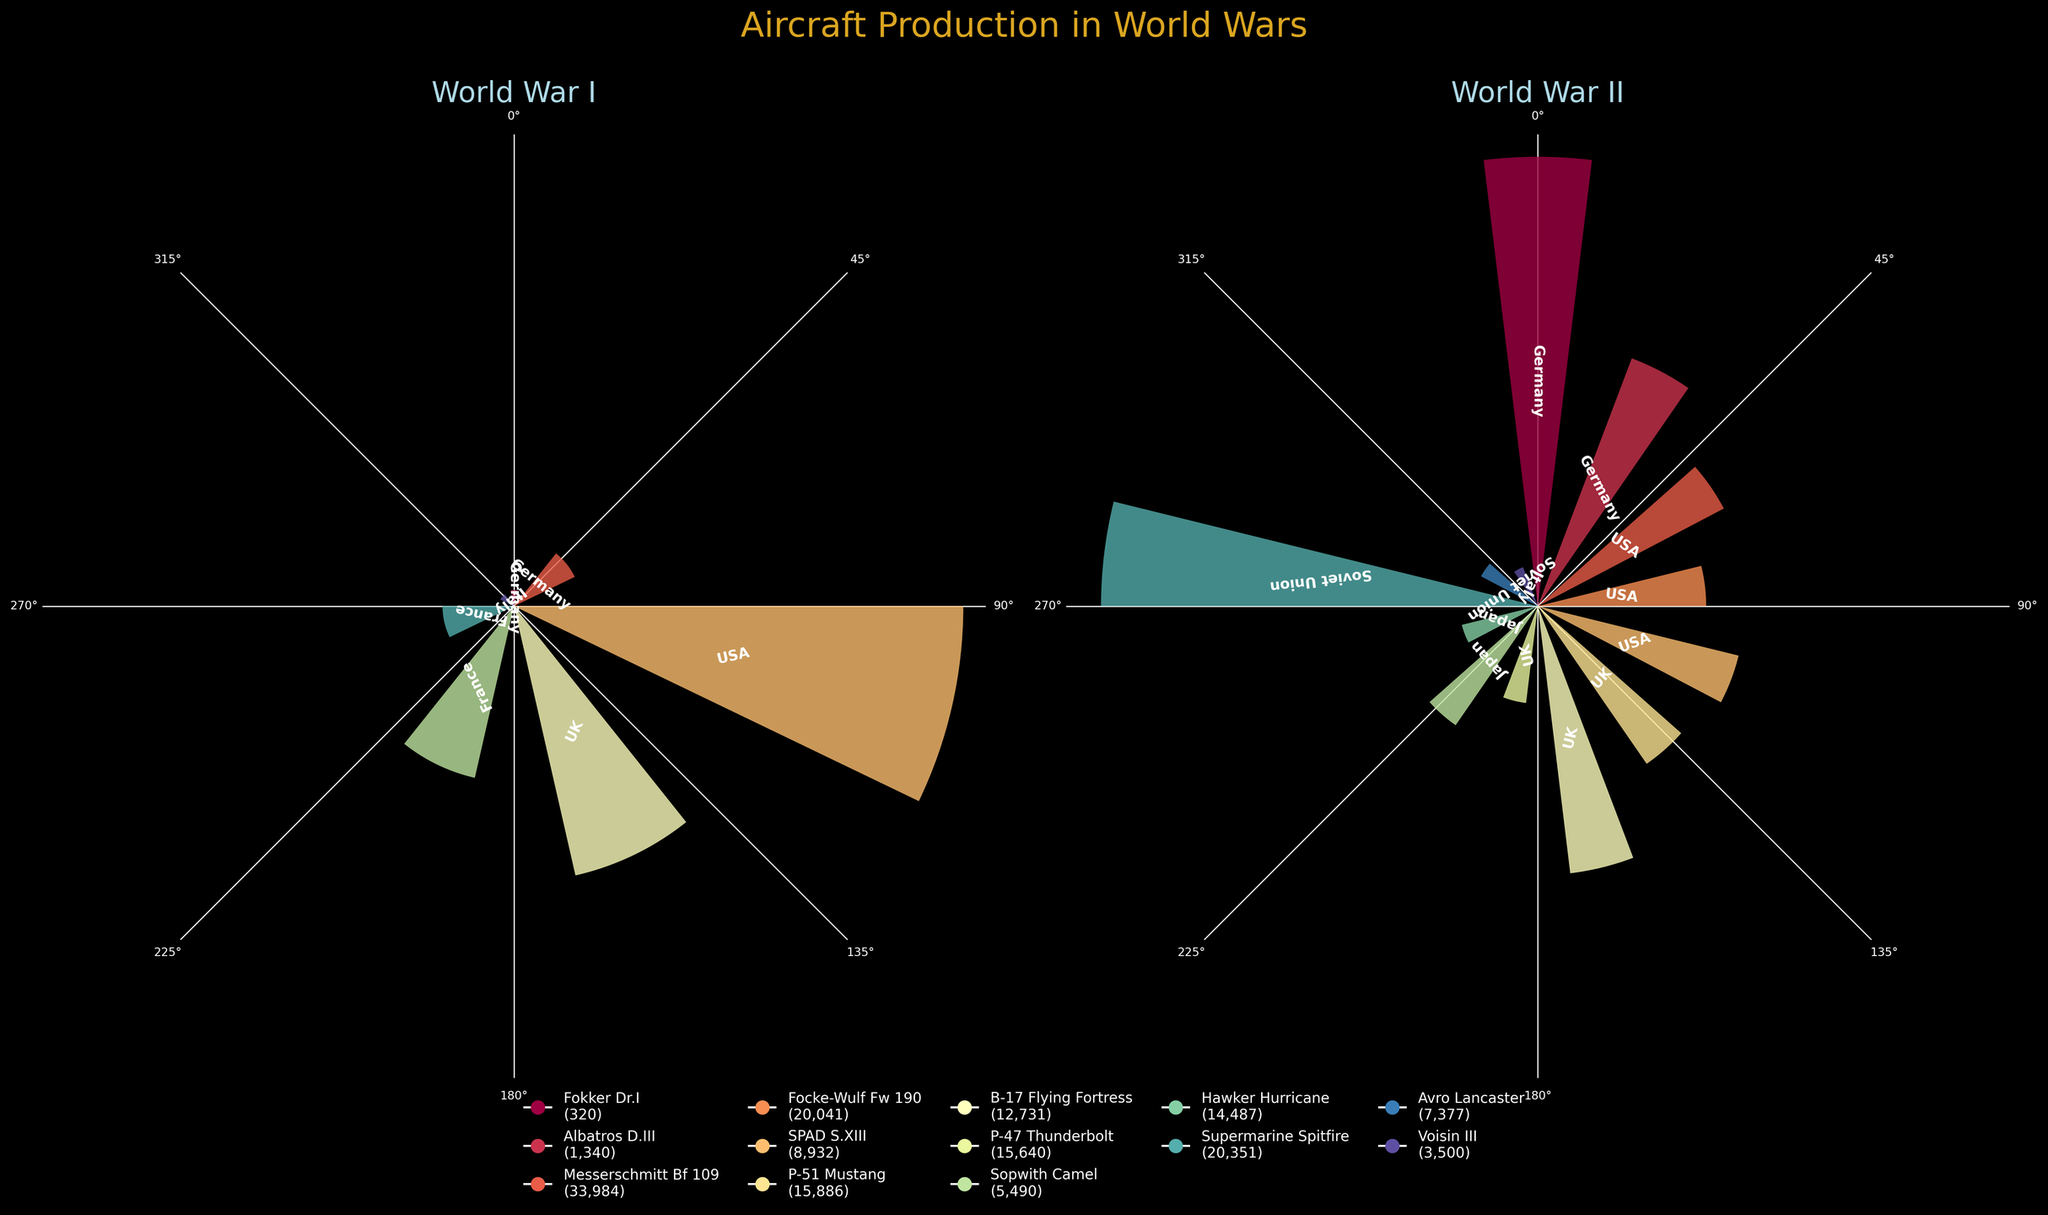Which country produced the largest number of aircraft during WWI? Look at the 'World War I' plot and identify the country with the highest bar. This is the USA with the SPAD S.XIII having the highest production value of 8932 units.
Answer: USA Which country made the most models of aircraft in WWII? In the 'World War II' plot, count the number of different models for each country. Germany, with the Messerschmitt Bf 109 and the Focke-Wulf Fw 190, appears twice. The USA has the most models with the P-51 Mustang, B-17 Flying Fortress, and P-47 Thunderbolt.
Answer: USA What was the production quantity of the Supermarine Spitfire? On the 'World War II' plot, find the bar associated with the UK and the Supermarine Spitfire. The production quantity is labeled as 20351 units.
Answer: 20351 Compare the total aircraft production of Germany in WWI and WWII. Which is higher, and by how much? In WWI, Germany's total production is the sum of the Fokker Dr.I (320 units) and Albatros D.III (1340 units) making 1660 units. In WWII, it’s the sum of the Messerschmitt Bf 109 (33984 units) and Focke-Wulf Fw 190 (20041 units) making 54025 units. The difference in production is 54025 - 1660 = 52365 units.
Answer: WWII by 52365 units Which country’s aircraft had the highest production quantity among all the models listed? Review both plots to identify the model with the highest production quantity. The US SPAD S.XIII in WWI has 8932 units, whereas the Soviet Union's Polikarpov Po-2 in WWII has 33037 units, which is the highest.
Answer: Soviet Union How many aircraft models were produced by Italy in both wars combined? Identify the number of unique bars associated with Italy in both plots. Italy has the Caproni Ca.3 in WWI and the Fiat G.55 in WWII. This leads to a total of 2 models.
Answer: 2 Which three aircraft models had the highest production values in WWII? On the 'World War II' plot, identify the three highest bars. These are the Messerschmitt Bf 109 (33984 units), the Polikarpov Po-2 (33037 units), and the Supermarine Spitfire (20351 units).
Answer: Messerschmitt Bf 109, Polikarpov Po-2, Supermarine Spitfire Does Japan have any aircraft production recorded for WWI? In the 'World War I' plot, inspect the bars and labels for any entry under Japan. Japan does not have any recorded aircraft production in WWI.
Answer: No Compare the production quantity of the UK’s Sopwith Camel in WWI to its Avro Lancaster in WWII. Which model had higher production? Identify the production values on both plots. The Sopwith Camel has 5490 units in WWI, while the Avro Lancaster has 7377 units in WWII. The Avro Lancaster has higher production.
Answer: Avro Lancaster What is the total production of German aircraft models in WWII? Sum up the production values of Germany's aircraft models in WWII. The Messerschmitt Bf 109 (33984 units) and Focke-Wulf Fw 190 (20041 units) together make a total of 33984 + 20041 = 54025 units.
Answer: 54025 